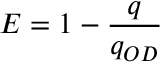<formula> <loc_0><loc_0><loc_500><loc_500>E = 1 - \frac { q } { q _ { O D } }</formula> 